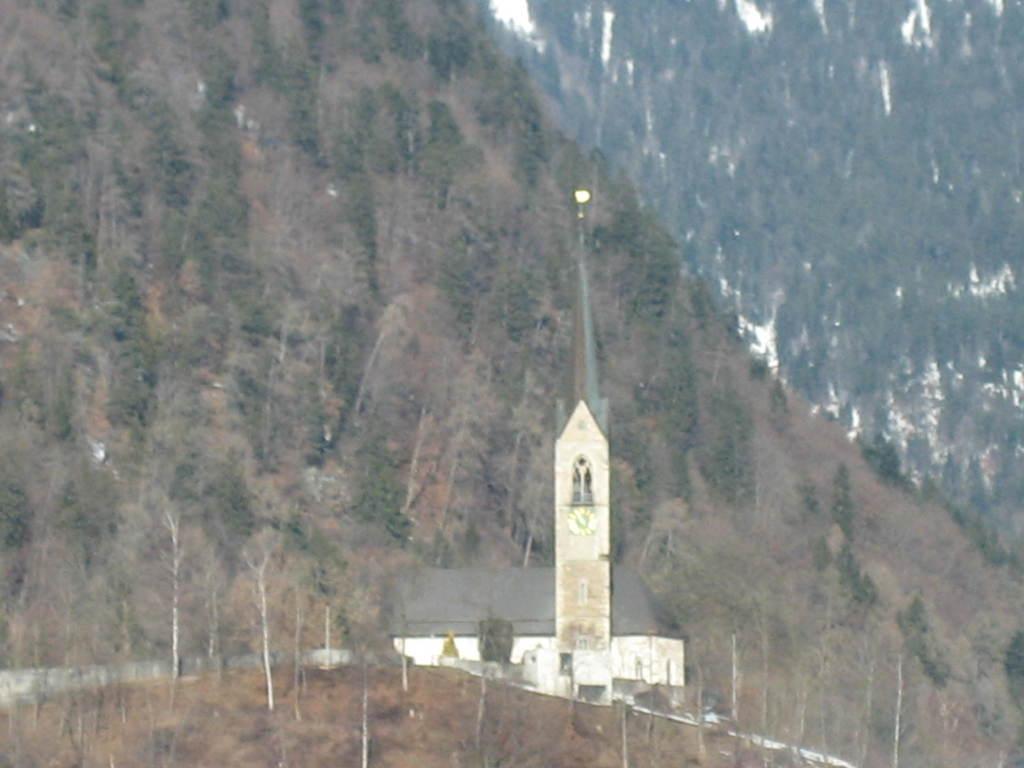In one or two sentences, can you explain what this image depicts? In this image we can see a house, pole, light, wall, trees, and mountain. 